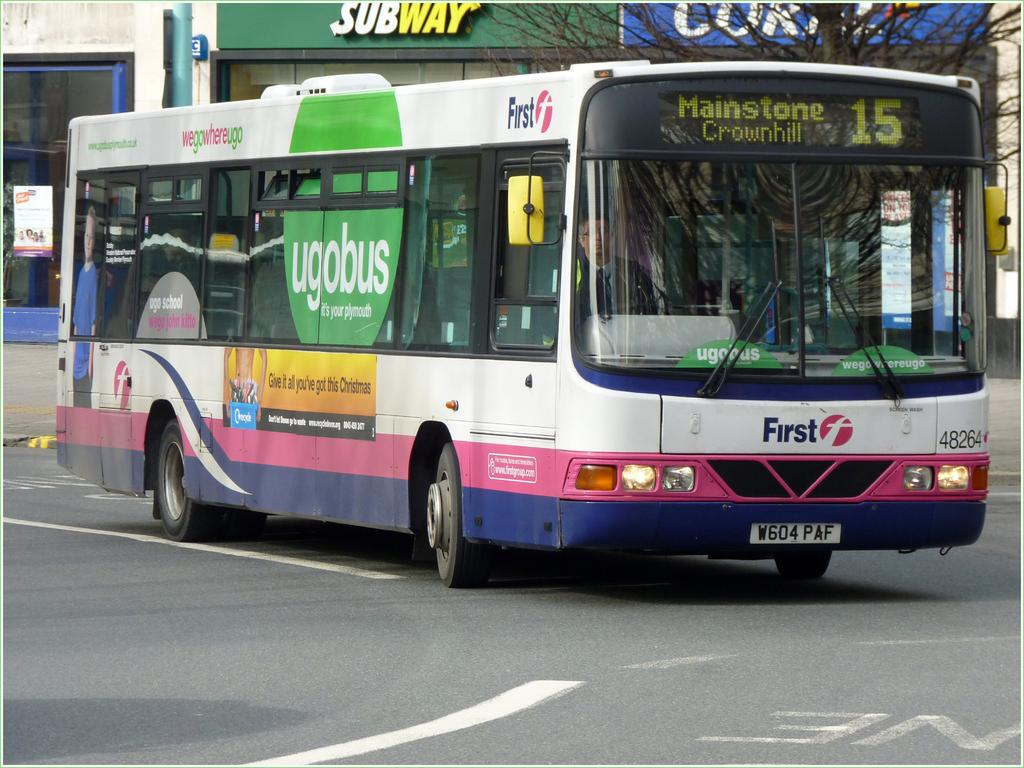<image>
Relay a brief, clear account of the picture shown. a bus heading to Mainstone with a Subway behind 